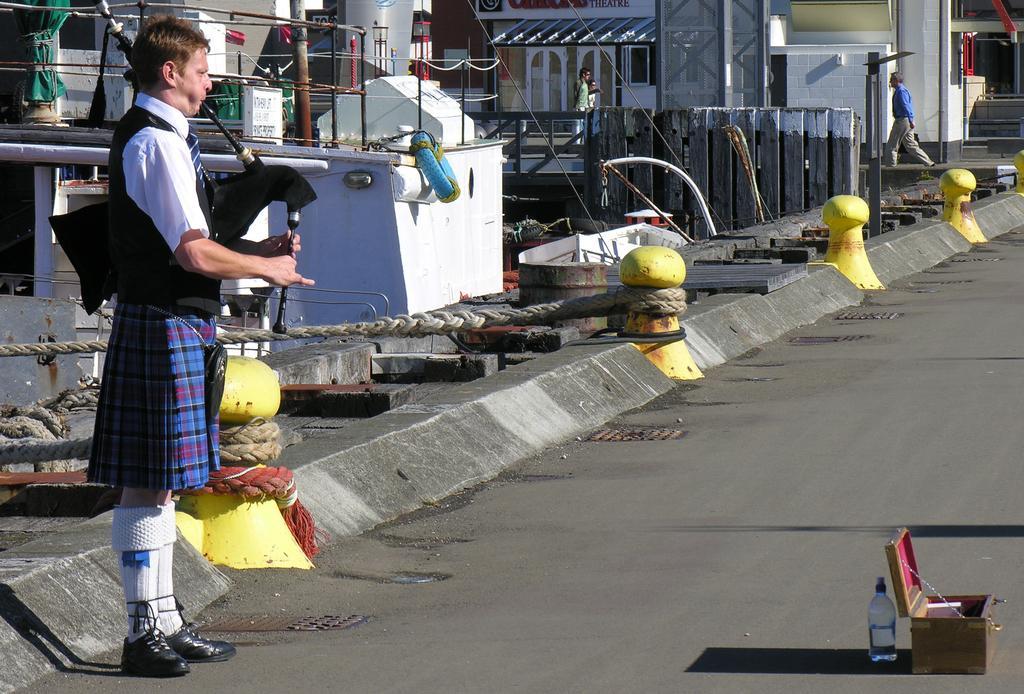Could you give a brief overview of what you see in this image? This picture describes about group of people, in the left side of the image we can see a man, he is playing a musical instrument, in front of him we can see a box and a bottle, behind to him we can find few ropes and metal rods, in the background we can see few houses. 